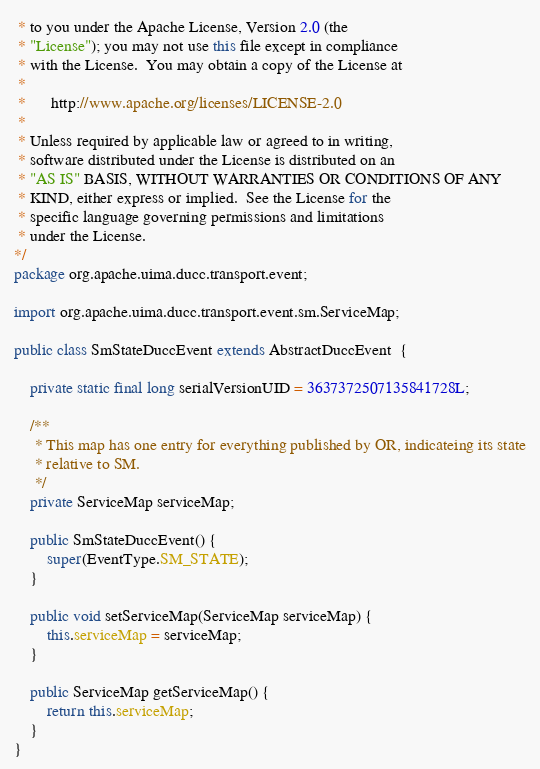Convert code to text. <code><loc_0><loc_0><loc_500><loc_500><_Java_> * to you under the Apache License, Version 2.0 (the
 * "License"); you may not use this file except in compliance
 * with the License.  You may obtain a copy of the License at
 * 
 *      http://www.apache.org/licenses/LICENSE-2.0
 * 
 * Unless required by applicable law or agreed to in writing,
 * software distributed under the License is distributed on an
 * "AS IS" BASIS, WITHOUT WARRANTIES OR CONDITIONS OF ANY
 * KIND, either express or implied.  See the License for the
 * specific language governing permissions and limitations
 * under the License.
*/
package org.apache.uima.ducc.transport.event;

import org.apache.uima.ducc.transport.event.sm.ServiceMap;

public class SmStateDuccEvent extends AbstractDuccEvent  {

	private static final long serialVersionUID = 3637372507135841728L;

    /**
     * This map has one entry for everything published by OR, indicateing its state
     * relative to SM.
     */
	private ServiceMap serviceMap;
	
	public SmStateDuccEvent() {
		super(EventType.SM_STATE);
	}
	
	public void setServiceMap(ServiceMap serviceMap) {
		this.serviceMap = serviceMap;
	}
	
	public ServiceMap getServiceMap() {
		return this.serviceMap;
	}
}
</code> 